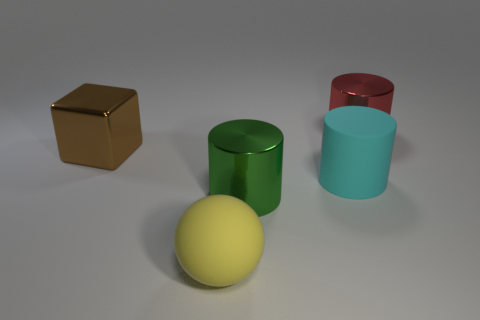Is there any object that/which reflects more light than the others? Yes, the green and red cylinders have a shinier surface compared to the brown cube and the yellow sphere, which have a matte finish. 